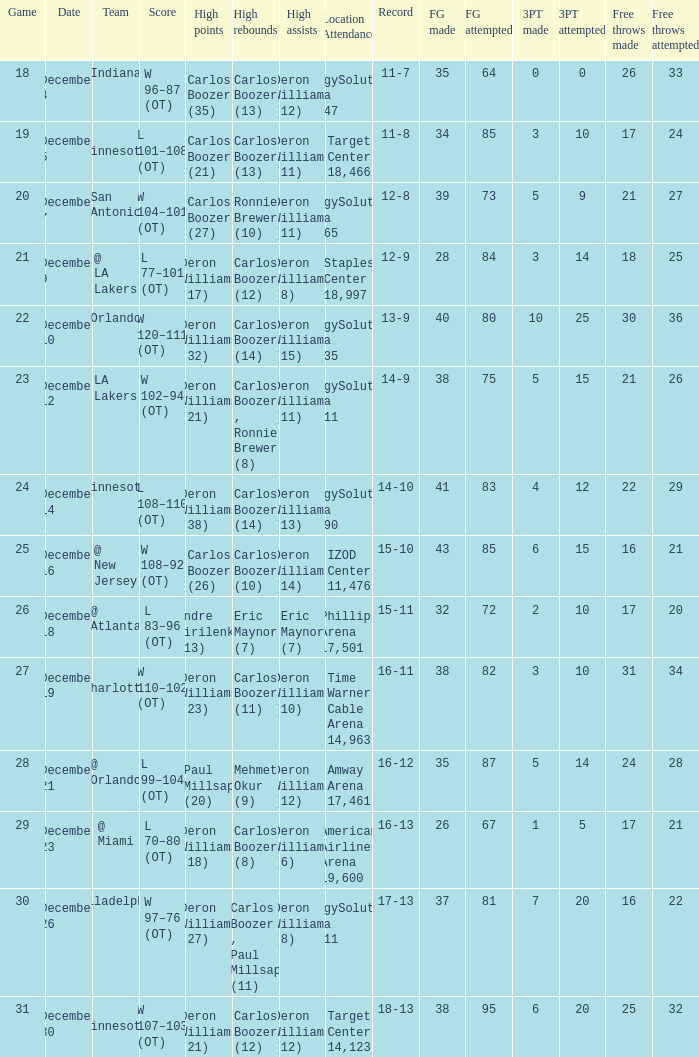How many different high rebound results are there for the game number 26? 1.0. 